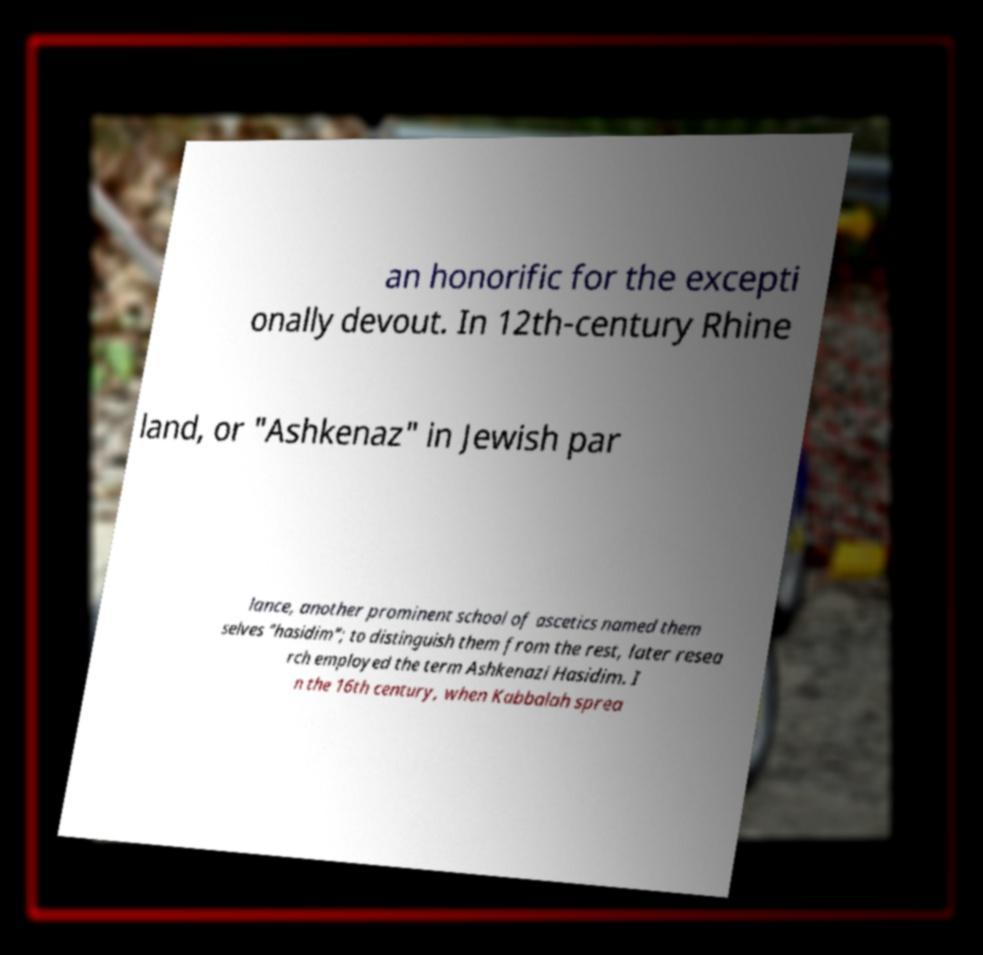Could you assist in decoding the text presented in this image and type it out clearly? an honorific for the excepti onally devout. In 12th-century Rhine land, or "Ashkenaz" in Jewish par lance, another prominent school of ascetics named them selves "hasidim"; to distinguish them from the rest, later resea rch employed the term Ashkenazi Hasidim. I n the 16th century, when Kabbalah sprea 